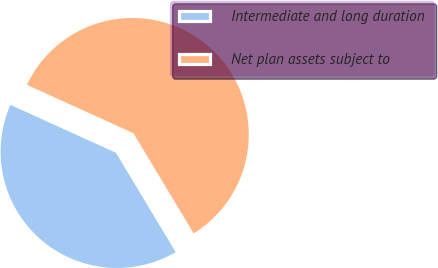<chart> <loc_0><loc_0><loc_500><loc_500><pie_chart><fcel>Intermediate and long duration<fcel>Net plan assets subject to<nl><fcel>40.4%<fcel>59.6%<nl></chart> 